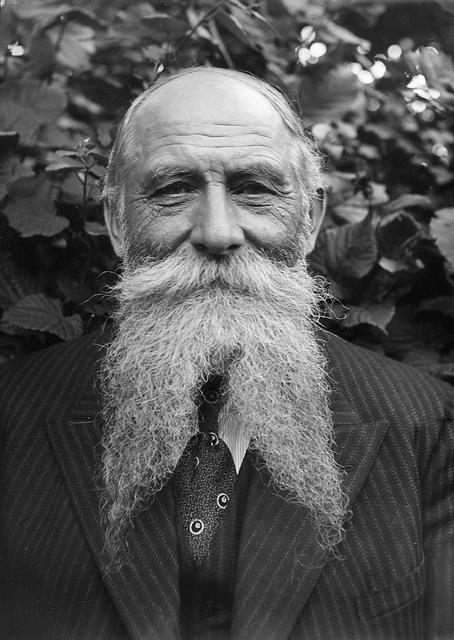Is the man wearing glasses?
Write a very short answer. No. Is the man happy?
Answer briefly. Yes. Is the man's beard neatly trimmed?
Write a very short answer. No. 